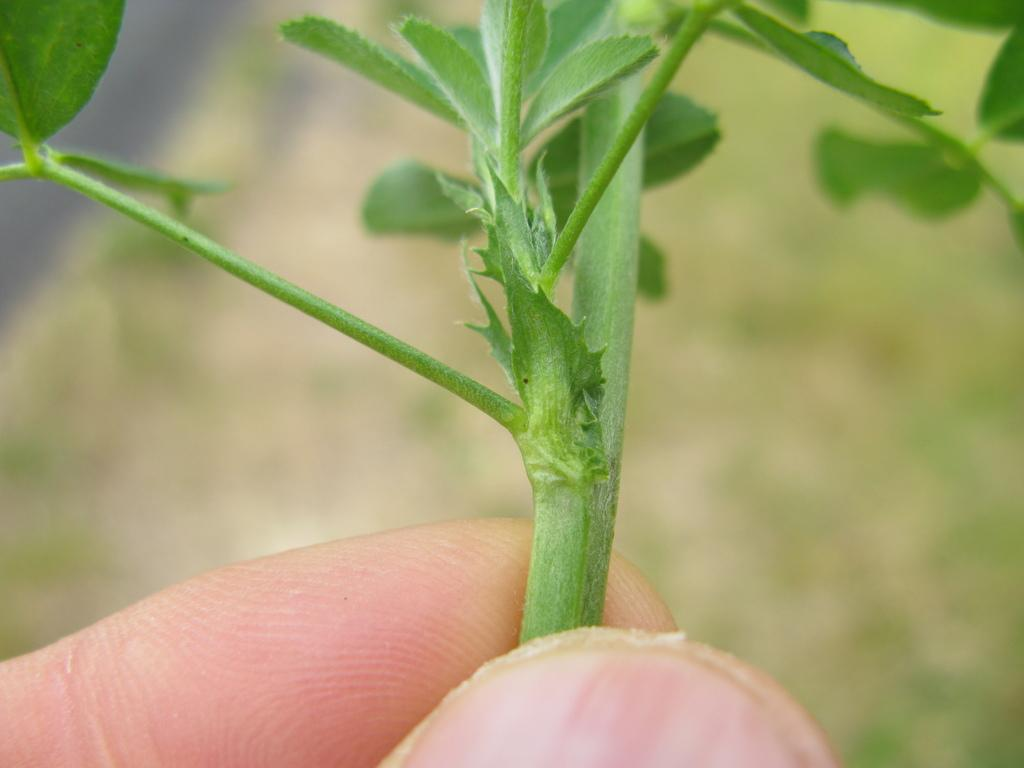What is present in the image? There is a person in the image. What part of the person's body can be seen? The person's hands are visible. What is the person holding in their hands? The person is holding a stem of a plant. What type of bread is the person using as a guide during the rainstorm in the image? There is no bread or rainstorm present in the image; it features a person holding a stem of a plant. 